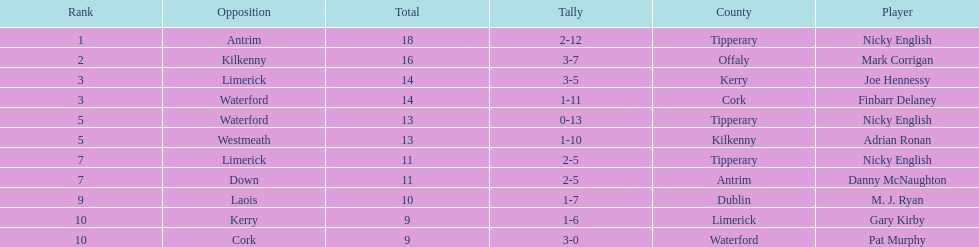What player got 10 total points in their game? M. J. Ryan. 